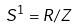<formula> <loc_0><loc_0><loc_500><loc_500>S ^ { 1 } = R / Z</formula> 